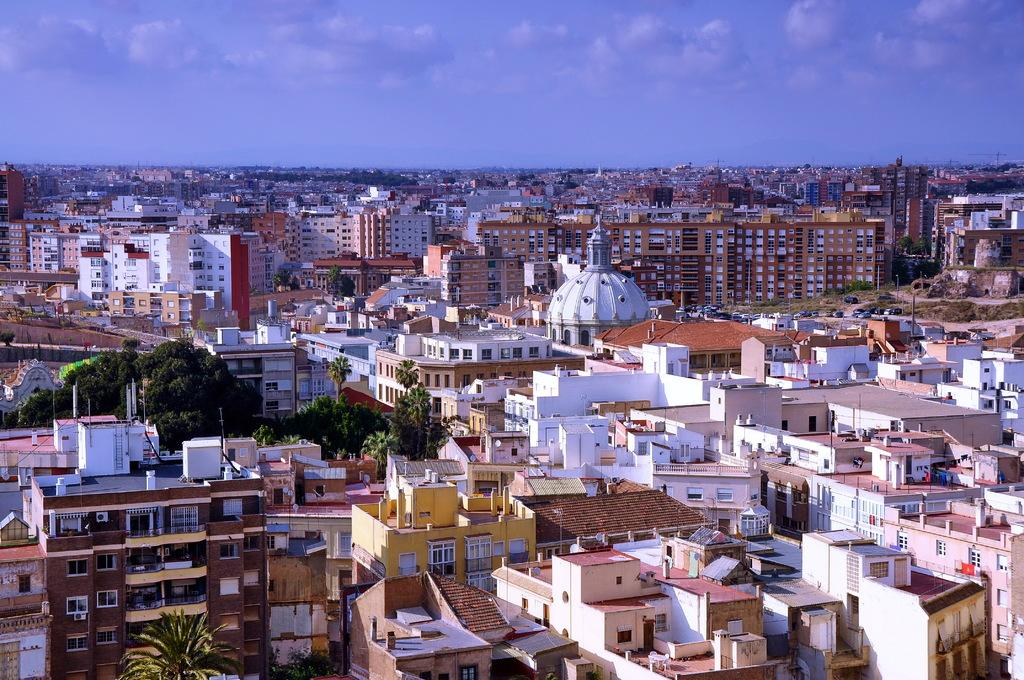What type of structures are present in the image? There are buildings in the image. What other natural elements can be seen in the image? There are trees in the image. What is visible at the top of the image? The sky is visible at the top of the image. What feature can be observed on the buildings? There are windows visible on the buildings. What type of game is being played by the minister in the image? There is no minister or game present in the image. What is the weight of the trees in the image? The weight of the trees cannot be determined from the image alone, as it does not provide information about their size or density. 